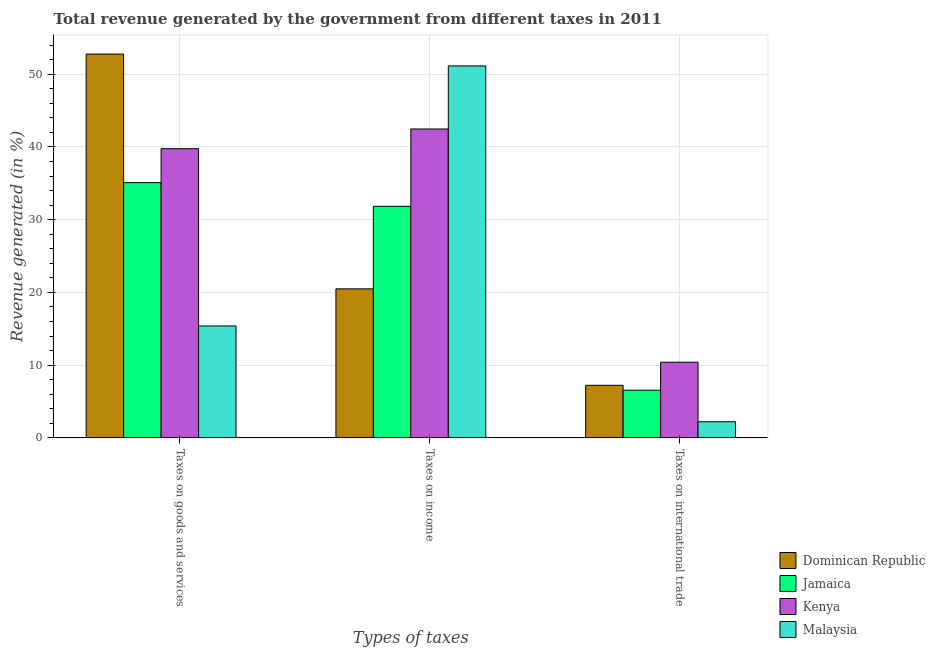How many groups of bars are there?
Give a very brief answer. 3. Are the number of bars on each tick of the X-axis equal?
Provide a succinct answer. Yes. What is the label of the 2nd group of bars from the left?
Offer a very short reply. Taxes on income. What is the percentage of revenue generated by taxes on income in Malaysia?
Ensure brevity in your answer.  51.15. Across all countries, what is the maximum percentage of revenue generated by tax on international trade?
Your response must be concise. 10.4. Across all countries, what is the minimum percentage of revenue generated by tax on international trade?
Your answer should be compact. 2.21. In which country was the percentage of revenue generated by taxes on goods and services maximum?
Ensure brevity in your answer.  Dominican Republic. In which country was the percentage of revenue generated by taxes on income minimum?
Provide a succinct answer. Dominican Republic. What is the total percentage of revenue generated by taxes on income in the graph?
Your response must be concise. 145.95. What is the difference between the percentage of revenue generated by tax on international trade in Malaysia and that in Dominican Republic?
Your answer should be very brief. -5.01. What is the difference between the percentage of revenue generated by taxes on income in Malaysia and the percentage of revenue generated by taxes on goods and services in Jamaica?
Provide a succinct answer. 16.05. What is the average percentage of revenue generated by taxes on income per country?
Ensure brevity in your answer.  36.49. What is the difference between the percentage of revenue generated by taxes on goods and services and percentage of revenue generated by tax on international trade in Kenya?
Your answer should be compact. 29.37. In how many countries, is the percentage of revenue generated by tax on international trade greater than 2 %?
Provide a short and direct response. 4. What is the ratio of the percentage of revenue generated by taxes on income in Malaysia to that in Kenya?
Your answer should be compact. 1.2. Is the percentage of revenue generated by taxes on goods and services in Malaysia less than that in Dominican Republic?
Offer a terse response. Yes. Is the difference between the percentage of revenue generated by tax on international trade in Jamaica and Dominican Republic greater than the difference between the percentage of revenue generated by taxes on income in Jamaica and Dominican Republic?
Provide a short and direct response. No. What is the difference between the highest and the second highest percentage of revenue generated by taxes on income?
Give a very brief answer. 8.67. What is the difference between the highest and the lowest percentage of revenue generated by taxes on goods and services?
Ensure brevity in your answer.  37.39. In how many countries, is the percentage of revenue generated by taxes on goods and services greater than the average percentage of revenue generated by taxes on goods and services taken over all countries?
Give a very brief answer. 2. Is the sum of the percentage of revenue generated by taxes on income in Dominican Republic and Jamaica greater than the maximum percentage of revenue generated by tax on international trade across all countries?
Keep it short and to the point. Yes. What does the 3rd bar from the left in Taxes on income represents?
Your answer should be very brief. Kenya. What does the 2nd bar from the right in Taxes on income represents?
Keep it short and to the point. Kenya. Is it the case that in every country, the sum of the percentage of revenue generated by taxes on goods and services and percentage of revenue generated by taxes on income is greater than the percentage of revenue generated by tax on international trade?
Ensure brevity in your answer.  Yes. How many bars are there?
Give a very brief answer. 12. What is the difference between two consecutive major ticks on the Y-axis?
Offer a very short reply. 10. Are the values on the major ticks of Y-axis written in scientific E-notation?
Provide a succinct answer. No. Does the graph contain grids?
Make the answer very short. Yes. How many legend labels are there?
Your answer should be compact. 4. How are the legend labels stacked?
Provide a succinct answer. Vertical. What is the title of the graph?
Give a very brief answer. Total revenue generated by the government from different taxes in 2011. What is the label or title of the X-axis?
Provide a succinct answer. Types of taxes. What is the label or title of the Y-axis?
Provide a succinct answer. Revenue generated (in %). What is the Revenue generated (in %) in Dominican Republic in Taxes on goods and services?
Your answer should be compact. 52.78. What is the Revenue generated (in %) of Jamaica in Taxes on goods and services?
Your response must be concise. 35.1. What is the Revenue generated (in %) of Kenya in Taxes on goods and services?
Provide a succinct answer. 39.77. What is the Revenue generated (in %) in Malaysia in Taxes on goods and services?
Provide a short and direct response. 15.39. What is the Revenue generated (in %) in Dominican Republic in Taxes on income?
Offer a terse response. 20.49. What is the Revenue generated (in %) in Jamaica in Taxes on income?
Offer a very short reply. 31.84. What is the Revenue generated (in %) in Kenya in Taxes on income?
Ensure brevity in your answer.  42.47. What is the Revenue generated (in %) of Malaysia in Taxes on income?
Make the answer very short. 51.15. What is the Revenue generated (in %) in Dominican Republic in Taxes on international trade?
Keep it short and to the point. 7.23. What is the Revenue generated (in %) in Jamaica in Taxes on international trade?
Provide a succinct answer. 6.55. What is the Revenue generated (in %) in Kenya in Taxes on international trade?
Keep it short and to the point. 10.4. What is the Revenue generated (in %) of Malaysia in Taxes on international trade?
Offer a very short reply. 2.21. Across all Types of taxes, what is the maximum Revenue generated (in %) of Dominican Republic?
Make the answer very short. 52.78. Across all Types of taxes, what is the maximum Revenue generated (in %) in Jamaica?
Your answer should be compact. 35.1. Across all Types of taxes, what is the maximum Revenue generated (in %) in Kenya?
Keep it short and to the point. 42.47. Across all Types of taxes, what is the maximum Revenue generated (in %) in Malaysia?
Your answer should be very brief. 51.15. Across all Types of taxes, what is the minimum Revenue generated (in %) in Dominican Republic?
Ensure brevity in your answer.  7.23. Across all Types of taxes, what is the minimum Revenue generated (in %) in Jamaica?
Make the answer very short. 6.55. Across all Types of taxes, what is the minimum Revenue generated (in %) of Kenya?
Your response must be concise. 10.4. Across all Types of taxes, what is the minimum Revenue generated (in %) of Malaysia?
Provide a short and direct response. 2.21. What is the total Revenue generated (in %) of Dominican Republic in the graph?
Ensure brevity in your answer.  80.5. What is the total Revenue generated (in %) of Jamaica in the graph?
Offer a very short reply. 73.49. What is the total Revenue generated (in %) in Kenya in the graph?
Ensure brevity in your answer.  92.64. What is the total Revenue generated (in %) in Malaysia in the graph?
Offer a terse response. 68.75. What is the difference between the Revenue generated (in %) of Dominican Republic in Taxes on goods and services and that in Taxes on income?
Give a very brief answer. 32.29. What is the difference between the Revenue generated (in %) of Jamaica in Taxes on goods and services and that in Taxes on income?
Offer a very short reply. 3.26. What is the difference between the Revenue generated (in %) of Kenya in Taxes on goods and services and that in Taxes on income?
Your answer should be compact. -2.71. What is the difference between the Revenue generated (in %) in Malaysia in Taxes on goods and services and that in Taxes on income?
Offer a terse response. -35.76. What is the difference between the Revenue generated (in %) in Dominican Republic in Taxes on goods and services and that in Taxes on international trade?
Provide a succinct answer. 45.55. What is the difference between the Revenue generated (in %) in Jamaica in Taxes on goods and services and that in Taxes on international trade?
Your response must be concise. 28.54. What is the difference between the Revenue generated (in %) in Kenya in Taxes on goods and services and that in Taxes on international trade?
Ensure brevity in your answer.  29.37. What is the difference between the Revenue generated (in %) of Malaysia in Taxes on goods and services and that in Taxes on international trade?
Ensure brevity in your answer.  13.18. What is the difference between the Revenue generated (in %) of Dominican Republic in Taxes on income and that in Taxes on international trade?
Your answer should be very brief. 13.26. What is the difference between the Revenue generated (in %) of Jamaica in Taxes on income and that in Taxes on international trade?
Provide a succinct answer. 25.29. What is the difference between the Revenue generated (in %) in Kenya in Taxes on income and that in Taxes on international trade?
Make the answer very short. 32.07. What is the difference between the Revenue generated (in %) in Malaysia in Taxes on income and that in Taxes on international trade?
Offer a terse response. 48.93. What is the difference between the Revenue generated (in %) in Dominican Republic in Taxes on goods and services and the Revenue generated (in %) in Jamaica in Taxes on income?
Give a very brief answer. 20.94. What is the difference between the Revenue generated (in %) of Dominican Republic in Taxes on goods and services and the Revenue generated (in %) of Kenya in Taxes on income?
Your answer should be very brief. 10.3. What is the difference between the Revenue generated (in %) in Dominican Republic in Taxes on goods and services and the Revenue generated (in %) in Malaysia in Taxes on income?
Give a very brief answer. 1.63. What is the difference between the Revenue generated (in %) in Jamaica in Taxes on goods and services and the Revenue generated (in %) in Kenya in Taxes on income?
Make the answer very short. -7.38. What is the difference between the Revenue generated (in %) of Jamaica in Taxes on goods and services and the Revenue generated (in %) of Malaysia in Taxes on income?
Your answer should be very brief. -16.05. What is the difference between the Revenue generated (in %) in Kenya in Taxes on goods and services and the Revenue generated (in %) in Malaysia in Taxes on income?
Your answer should be compact. -11.38. What is the difference between the Revenue generated (in %) of Dominican Republic in Taxes on goods and services and the Revenue generated (in %) of Jamaica in Taxes on international trade?
Provide a short and direct response. 46.22. What is the difference between the Revenue generated (in %) of Dominican Republic in Taxes on goods and services and the Revenue generated (in %) of Kenya in Taxes on international trade?
Make the answer very short. 42.38. What is the difference between the Revenue generated (in %) of Dominican Republic in Taxes on goods and services and the Revenue generated (in %) of Malaysia in Taxes on international trade?
Provide a short and direct response. 50.56. What is the difference between the Revenue generated (in %) in Jamaica in Taxes on goods and services and the Revenue generated (in %) in Kenya in Taxes on international trade?
Offer a terse response. 24.7. What is the difference between the Revenue generated (in %) of Jamaica in Taxes on goods and services and the Revenue generated (in %) of Malaysia in Taxes on international trade?
Your answer should be compact. 32.88. What is the difference between the Revenue generated (in %) of Kenya in Taxes on goods and services and the Revenue generated (in %) of Malaysia in Taxes on international trade?
Your response must be concise. 37.55. What is the difference between the Revenue generated (in %) in Dominican Republic in Taxes on income and the Revenue generated (in %) in Jamaica in Taxes on international trade?
Offer a terse response. 13.94. What is the difference between the Revenue generated (in %) in Dominican Republic in Taxes on income and the Revenue generated (in %) in Kenya in Taxes on international trade?
Offer a terse response. 10.09. What is the difference between the Revenue generated (in %) of Dominican Republic in Taxes on income and the Revenue generated (in %) of Malaysia in Taxes on international trade?
Ensure brevity in your answer.  18.28. What is the difference between the Revenue generated (in %) of Jamaica in Taxes on income and the Revenue generated (in %) of Kenya in Taxes on international trade?
Keep it short and to the point. 21.44. What is the difference between the Revenue generated (in %) in Jamaica in Taxes on income and the Revenue generated (in %) in Malaysia in Taxes on international trade?
Your answer should be very brief. 29.62. What is the difference between the Revenue generated (in %) of Kenya in Taxes on income and the Revenue generated (in %) of Malaysia in Taxes on international trade?
Provide a short and direct response. 40.26. What is the average Revenue generated (in %) of Dominican Republic per Types of taxes?
Ensure brevity in your answer.  26.83. What is the average Revenue generated (in %) of Jamaica per Types of taxes?
Your answer should be very brief. 24.5. What is the average Revenue generated (in %) of Kenya per Types of taxes?
Your answer should be very brief. 30.88. What is the average Revenue generated (in %) of Malaysia per Types of taxes?
Provide a succinct answer. 22.92. What is the difference between the Revenue generated (in %) in Dominican Republic and Revenue generated (in %) in Jamaica in Taxes on goods and services?
Give a very brief answer. 17.68. What is the difference between the Revenue generated (in %) of Dominican Republic and Revenue generated (in %) of Kenya in Taxes on goods and services?
Make the answer very short. 13.01. What is the difference between the Revenue generated (in %) of Dominican Republic and Revenue generated (in %) of Malaysia in Taxes on goods and services?
Offer a terse response. 37.39. What is the difference between the Revenue generated (in %) in Jamaica and Revenue generated (in %) in Kenya in Taxes on goods and services?
Offer a terse response. -4.67. What is the difference between the Revenue generated (in %) of Jamaica and Revenue generated (in %) of Malaysia in Taxes on goods and services?
Your answer should be very brief. 19.71. What is the difference between the Revenue generated (in %) in Kenya and Revenue generated (in %) in Malaysia in Taxes on goods and services?
Ensure brevity in your answer.  24.38. What is the difference between the Revenue generated (in %) of Dominican Republic and Revenue generated (in %) of Jamaica in Taxes on income?
Your answer should be very brief. -11.35. What is the difference between the Revenue generated (in %) of Dominican Republic and Revenue generated (in %) of Kenya in Taxes on income?
Your response must be concise. -21.98. What is the difference between the Revenue generated (in %) of Dominican Republic and Revenue generated (in %) of Malaysia in Taxes on income?
Your answer should be compact. -30.66. What is the difference between the Revenue generated (in %) of Jamaica and Revenue generated (in %) of Kenya in Taxes on income?
Keep it short and to the point. -10.63. What is the difference between the Revenue generated (in %) of Jamaica and Revenue generated (in %) of Malaysia in Taxes on income?
Provide a short and direct response. -19.31. What is the difference between the Revenue generated (in %) of Kenya and Revenue generated (in %) of Malaysia in Taxes on income?
Ensure brevity in your answer.  -8.67. What is the difference between the Revenue generated (in %) in Dominican Republic and Revenue generated (in %) in Jamaica in Taxes on international trade?
Provide a succinct answer. 0.68. What is the difference between the Revenue generated (in %) of Dominican Republic and Revenue generated (in %) of Kenya in Taxes on international trade?
Provide a short and direct response. -3.17. What is the difference between the Revenue generated (in %) in Dominican Republic and Revenue generated (in %) in Malaysia in Taxes on international trade?
Keep it short and to the point. 5.01. What is the difference between the Revenue generated (in %) in Jamaica and Revenue generated (in %) in Kenya in Taxes on international trade?
Your response must be concise. -3.85. What is the difference between the Revenue generated (in %) of Jamaica and Revenue generated (in %) of Malaysia in Taxes on international trade?
Make the answer very short. 4.34. What is the difference between the Revenue generated (in %) of Kenya and Revenue generated (in %) of Malaysia in Taxes on international trade?
Ensure brevity in your answer.  8.19. What is the ratio of the Revenue generated (in %) in Dominican Republic in Taxes on goods and services to that in Taxes on income?
Provide a succinct answer. 2.58. What is the ratio of the Revenue generated (in %) in Jamaica in Taxes on goods and services to that in Taxes on income?
Give a very brief answer. 1.1. What is the ratio of the Revenue generated (in %) in Kenya in Taxes on goods and services to that in Taxes on income?
Your response must be concise. 0.94. What is the ratio of the Revenue generated (in %) in Malaysia in Taxes on goods and services to that in Taxes on income?
Make the answer very short. 0.3. What is the ratio of the Revenue generated (in %) of Dominican Republic in Taxes on goods and services to that in Taxes on international trade?
Offer a terse response. 7.3. What is the ratio of the Revenue generated (in %) of Jamaica in Taxes on goods and services to that in Taxes on international trade?
Keep it short and to the point. 5.36. What is the ratio of the Revenue generated (in %) of Kenya in Taxes on goods and services to that in Taxes on international trade?
Your answer should be compact. 3.82. What is the ratio of the Revenue generated (in %) of Malaysia in Taxes on goods and services to that in Taxes on international trade?
Make the answer very short. 6.95. What is the ratio of the Revenue generated (in %) in Dominican Republic in Taxes on income to that in Taxes on international trade?
Make the answer very short. 2.83. What is the ratio of the Revenue generated (in %) in Jamaica in Taxes on income to that in Taxes on international trade?
Your answer should be very brief. 4.86. What is the ratio of the Revenue generated (in %) in Kenya in Taxes on income to that in Taxes on international trade?
Offer a very short reply. 4.08. What is the ratio of the Revenue generated (in %) in Malaysia in Taxes on income to that in Taxes on international trade?
Give a very brief answer. 23.09. What is the difference between the highest and the second highest Revenue generated (in %) of Dominican Republic?
Ensure brevity in your answer.  32.29. What is the difference between the highest and the second highest Revenue generated (in %) in Jamaica?
Your answer should be very brief. 3.26. What is the difference between the highest and the second highest Revenue generated (in %) in Kenya?
Your answer should be compact. 2.71. What is the difference between the highest and the second highest Revenue generated (in %) in Malaysia?
Offer a terse response. 35.76. What is the difference between the highest and the lowest Revenue generated (in %) in Dominican Republic?
Offer a very short reply. 45.55. What is the difference between the highest and the lowest Revenue generated (in %) of Jamaica?
Offer a very short reply. 28.54. What is the difference between the highest and the lowest Revenue generated (in %) of Kenya?
Offer a terse response. 32.07. What is the difference between the highest and the lowest Revenue generated (in %) of Malaysia?
Offer a very short reply. 48.93. 